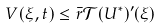<formula> <loc_0><loc_0><loc_500><loc_500>V ( \xi , t ) \leq \bar { r } \mathcal { T } ( U ^ { * } ) ^ { \prime } ( \xi )</formula> 